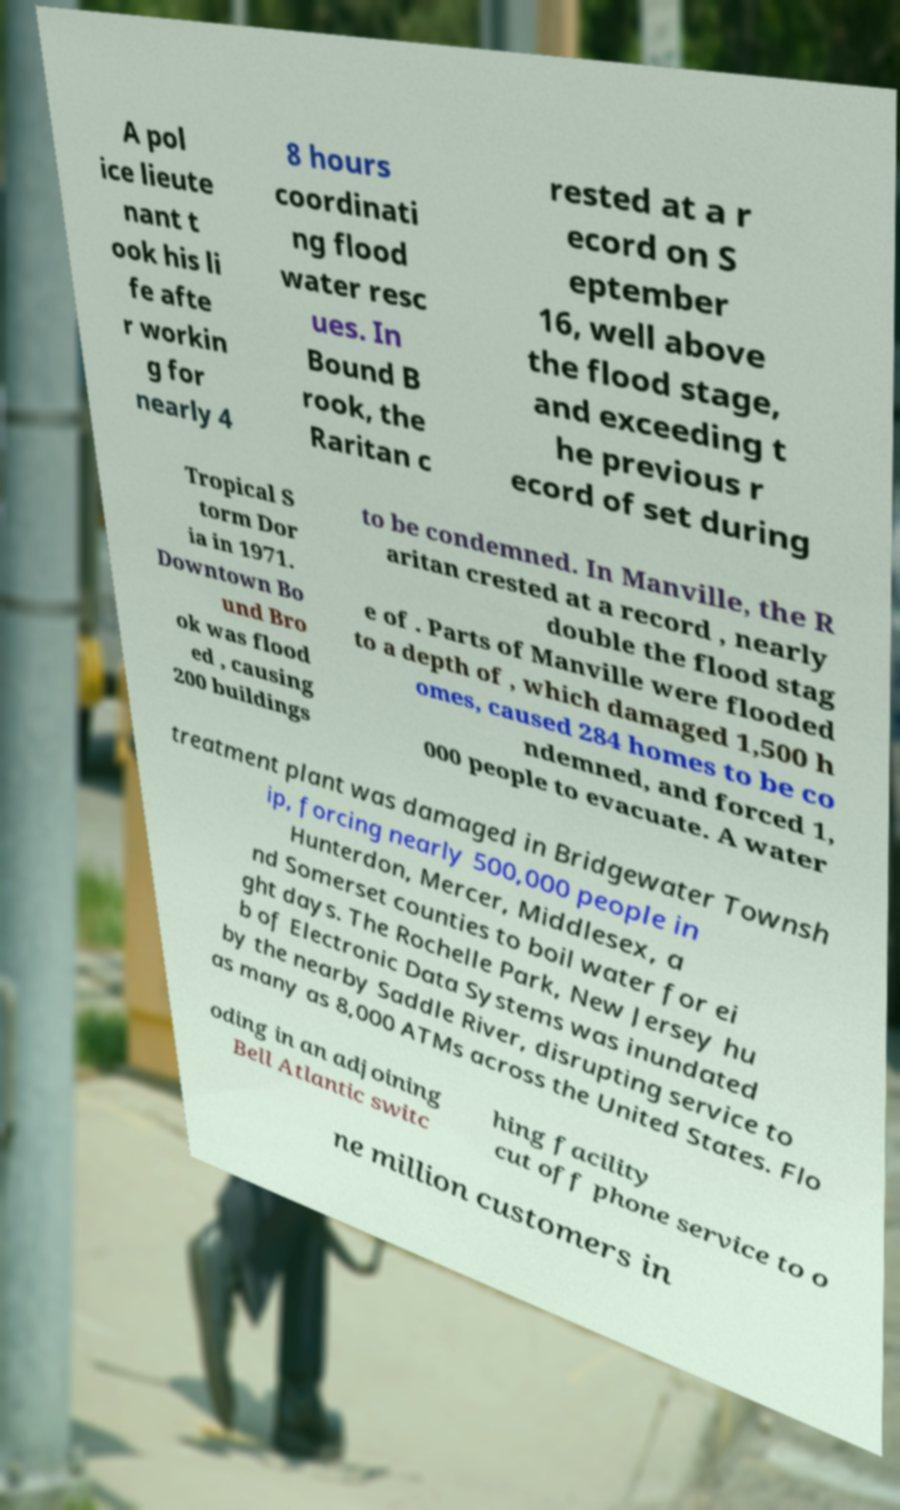There's text embedded in this image that I need extracted. Can you transcribe it verbatim? A pol ice lieute nant t ook his li fe afte r workin g for nearly 4 8 hours coordinati ng flood water resc ues. In Bound B rook, the Raritan c rested at a r ecord on S eptember 16, well above the flood stage, and exceeding t he previous r ecord of set during Tropical S torm Dor ia in 1971. Downtown Bo und Bro ok was flood ed , causing 200 buildings to be condemned. In Manville, the R aritan crested at a record , nearly double the flood stag e of . Parts of Manville were flooded to a depth of , which damaged 1,500 h omes, caused 284 homes to be co ndemned, and forced 1, 000 people to evacuate. A water treatment plant was damaged in Bridgewater Townsh ip, forcing nearly 500,000 people in Hunterdon, Mercer, Middlesex, a nd Somerset counties to boil water for ei ght days. The Rochelle Park, New Jersey hu b of Electronic Data Systems was inundated by the nearby Saddle River, disrupting service to as many as 8,000 ATMs across the United States. Flo oding in an adjoining Bell Atlantic switc hing facility cut off phone service to o ne million customers in 